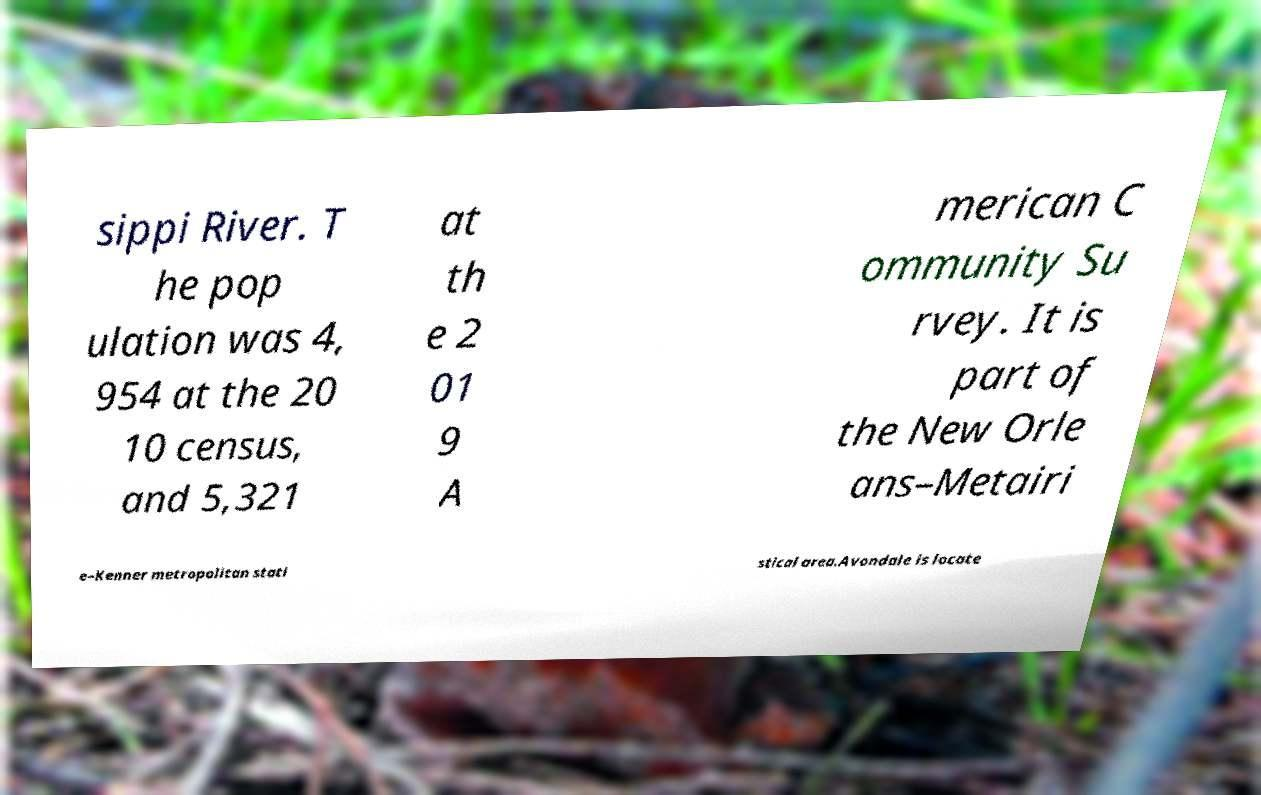Could you extract and type out the text from this image? sippi River. T he pop ulation was 4, 954 at the 20 10 census, and 5,321 at th e 2 01 9 A merican C ommunity Su rvey. It is part of the New Orle ans–Metairi e–Kenner metropolitan stati stical area.Avondale is locate 